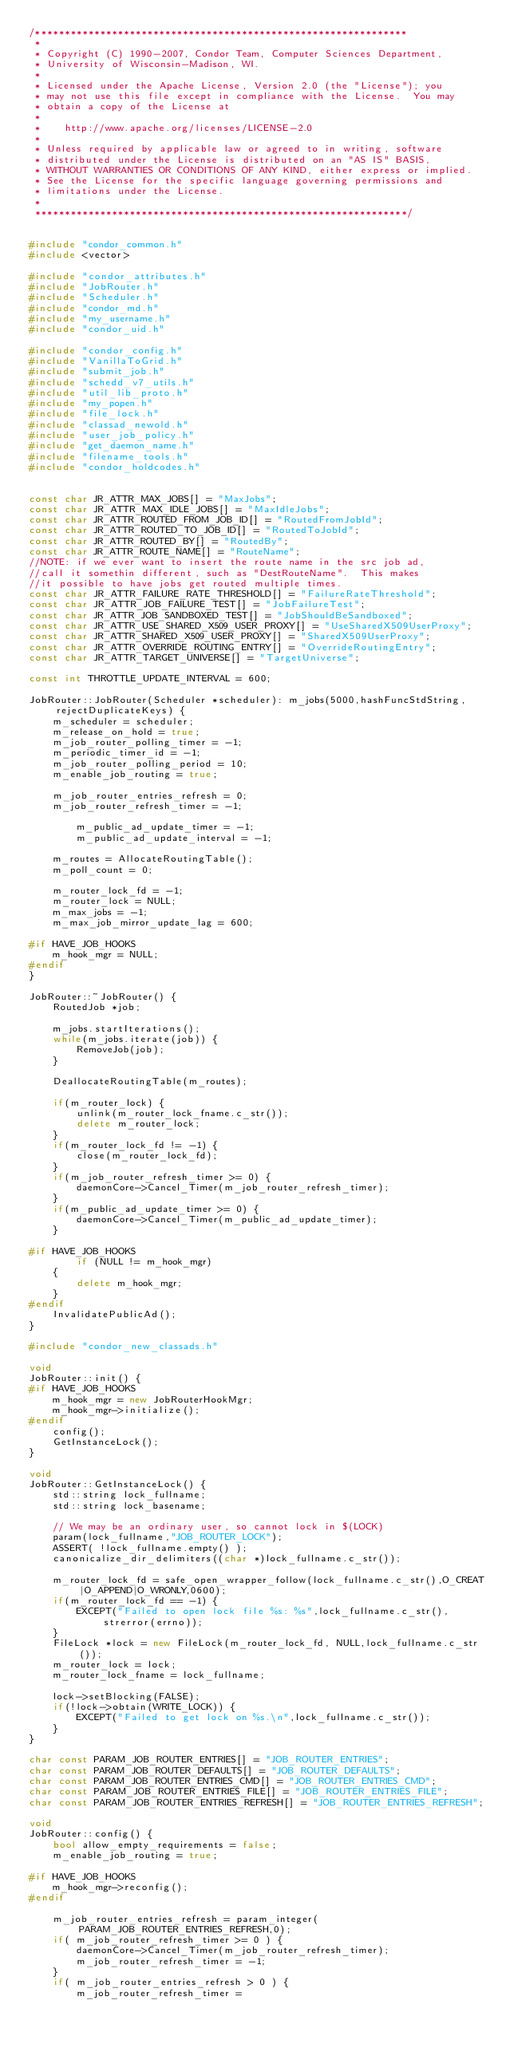<code> <loc_0><loc_0><loc_500><loc_500><_C++_>/***************************************************************
 *
 * Copyright (C) 1990-2007, Condor Team, Computer Sciences Department,
 * University of Wisconsin-Madison, WI.
 * 
 * Licensed under the Apache License, Version 2.0 (the "License"); you
 * may not use this file except in compliance with the License.  You may
 * obtain a copy of the License at
 * 
 *    http://www.apache.org/licenses/LICENSE-2.0
 * 
 * Unless required by applicable law or agreed to in writing, software
 * distributed under the License is distributed on an "AS IS" BASIS,
 * WITHOUT WARRANTIES OR CONDITIONS OF ANY KIND, either express or implied.
 * See the License for the specific language governing permissions and
 * limitations under the License.
 *
 ***************************************************************/


#include "condor_common.h"
#include <vector>

#include "condor_attributes.h"
#include "JobRouter.h"
#include "Scheduler.h"
#include "condor_md.h"
#include "my_username.h"
#include "condor_uid.h"

#include "condor_config.h"
#include "VanillaToGrid.h"
#include "submit_job.h"
#include "schedd_v7_utils.h"
#include "util_lib_proto.h"
#include "my_popen.h"
#include "file_lock.h"
#include "classad_newold.h"
#include "user_job_policy.h"
#include "get_daemon_name.h"
#include "filename_tools.h"
#include "condor_holdcodes.h"


const char JR_ATTR_MAX_JOBS[] = "MaxJobs";
const char JR_ATTR_MAX_IDLE_JOBS[] = "MaxIdleJobs";
const char JR_ATTR_ROUTED_FROM_JOB_ID[] = "RoutedFromJobId";
const char JR_ATTR_ROUTED_TO_JOB_ID[] = "RoutedToJobId";
const char JR_ATTR_ROUTED_BY[] = "RoutedBy";
const char JR_ATTR_ROUTE_NAME[] = "RouteName";
//NOTE: if we ever want to insert the route name in the src job ad,
//call it somethin different, such as "DestRouteName".  This makes
//it possible to have jobs get routed multiple times.
const char JR_ATTR_FAILURE_RATE_THRESHOLD[] = "FailureRateThreshold";
const char JR_ATTR_JOB_FAILURE_TEST[] = "JobFailureTest";
const char JR_ATTR_JOB_SANDBOXED_TEST[] = "JobShouldBeSandboxed";
const char JR_ATTR_USE_SHARED_X509_USER_PROXY[] = "UseSharedX509UserProxy";
const char JR_ATTR_SHARED_X509_USER_PROXY[] = "SharedX509UserProxy";
const char JR_ATTR_OVERRIDE_ROUTING_ENTRY[] = "OverrideRoutingEntry";
const char JR_ATTR_TARGET_UNIVERSE[] = "TargetUniverse";

const int THROTTLE_UPDATE_INTERVAL = 600;

JobRouter::JobRouter(Scheduler *scheduler): m_jobs(5000,hashFuncStdString,rejectDuplicateKeys) {
	m_scheduler = scheduler;
	m_release_on_hold = true;
	m_job_router_polling_timer = -1;
	m_periodic_timer_id = -1;
	m_job_router_polling_period = 10;
	m_enable_job_routing = true;

	m_job_router_entries_refresh = 0;
	m_job_router_refresh_timer = -1;

        m_public_ad_update_timer = -1;
        m_public_ad_update_interval = -1;

	m_routes = AllocateRoutingTable();
	m_poll_count = 0;

	m_router_lock_fd = -1;
	m_router_lock = NULL;
	m_max_jobs = -1;
	m_max_job_mirror_update_lag = 600;

#if HAVE_JOB_HOOKS
	m_hook_mgr = NULL;
#endif
}

JobRouter::~JobRouter() {
	RoutedJob *job;

	m_jobs.startIterations();
	while(m_jobs.iterate(job)) {
		RemoveJob(job);
	}

	DeallocateRoutingTable(m_routes);

	if(m_router_lock) {
		unlink(m_router_lock_fname.c_str());
		delete m_router_lock;
	}
	if(m_router_lock_fd != -1) {
		close(m_router_lock_fd);
	}
	if(m_job_router_refresh_timer >= 0) {
		daemonCore->Cancel_Timer(m_job_router_refresh_timer);
	}
	if(m_public_ad_update_timer >= 0) {
		daemonCore->Cancel_Timer(m_public_ad_update_timer);
	}

#if HAVE_JOB_HOOKS
        if (NULL != m_hook_mgr)
	{
		delete m_hook_mgr;
	}
#endif
	InvalidatePublicAd();
}

#include "condor_new_classads.h"

void
JobRouter::init() {
#if HAVE_JOB_HOOKS
	m_hook_mgr = new JobRouterHookMgr;
	m_hook_mgr->initialize();
#endif
	config();
	GetInstanceLock();
}

void
JobRouter::GetInstanceLock() {
	std::string lock_fullname;
	std::string lock_basename;

	// We may be an ordinary user, so cannot lock in $(LOCK)
	param(lock_fullname,"JOB_ROUTER_LOCK");
	ASSERT( !lock_fullname.empty() );
	canonicalize_dir_delimiters((char *)lock_fullname.c_str());

	m_router_lock_fd = safe_open_wrapper_follow(lock_fullname.c_str(),O_CREAT|O_APPEND|O_WRONLY,0600);
	if(m_router_lock_fd == -1) {
		EXCEPT("Failed to open lock file %s: %s",lock_fullname.c_str(),strerror(errno));
	}
	FileLock *lock = new FileLock(m_router_lock_fd, NULL,lock_fullname.c_str());
	m_router_lock = lock;
	m_router_lock_fname = lock_fullname;

	lock->setBlocking(FALSE);
	if(!lock->obtain(WRITE_LOCK)) {
		EXCEPT("Failed to get lock on %s.\n",lock_fullname.c_str());
	}
}

char const PARAM_JOB_ROUTER_ENTRIES[] = "JOB_ROUTER_ENTRIES";
char const PARAM_JOB_ROUTER_DEFAULTS[] = "JOB_ROUTER_DEFAULTS";
char const PARAM_JOB_ROUTER_ENTRIES_CMD[] = "JOB_ROUTER_ENTRIES_CMD";
char const PARAM_JOB_ROUTER_ENTRIES_FILE[] = "JOB_ROUTER_ENTRIES_FILE";
char const PARAM_JOB_ROUTER_ENTRIES_REFRESH[] = "JOB_ROUTER_ENTRIES_REFRESH";

void
JobRouter::config() {
	bool allow_empty_requirements = false;
	m_enable_job_routing = true;

#if HAVE_JOB_HOOKS
	m_hook_mgr->reconfig();
#endif

	m_job_router_entries_refresh = param_integer(PARAM_JOB_ROUTER_ENTRIES_REFRESH,0);
	if( m_job_router_refresh_timer >= 0 ) {
		daemonCore->Cancel_Timer(m_job_router_refresh_timer);
		m_job_router_refresh_timer = -1;
	}
	if( m_job_router_entries_refresh > 0 ) {
		m_job_router_refresh_timer = </code> 